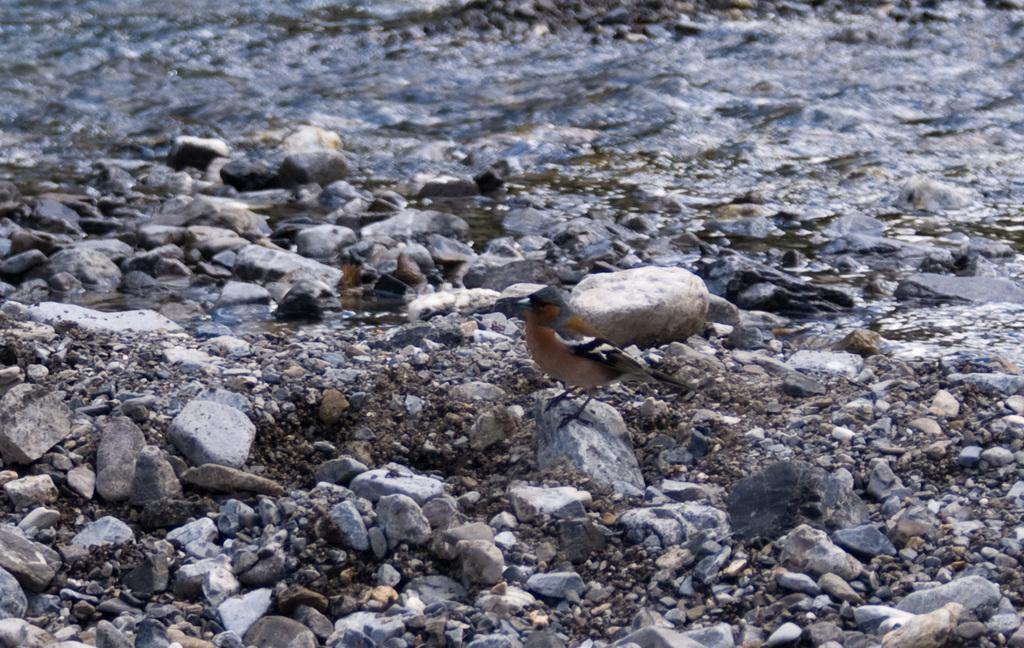What type of animal can be seen in the image? There is a bird in the image. What is the bird standing on? The bird is standing on a stone. What can be seen in the background of the image? There are many stones and water visible in the background of the image. What type of protest is the bird participating in on the stone? There is no protest present in the image; it is a bird standing on a stone. 